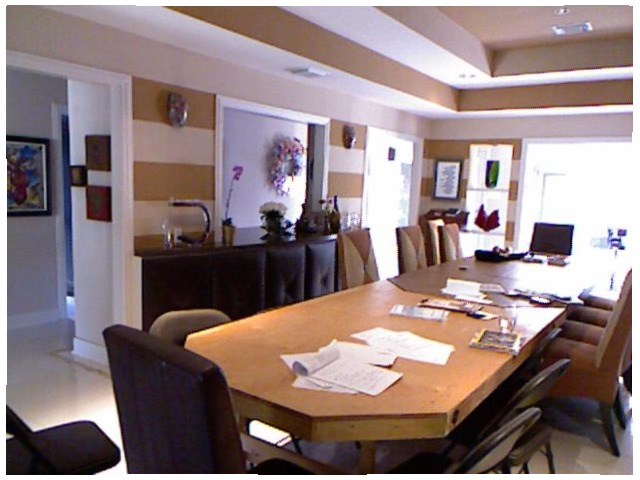<image>
Can you confirm if the glass is in front of the book? No. The glass is not in front of the book. The spatial positioning shows a different relationship between these objects. 